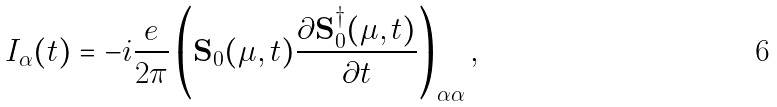<formula> <loc_0><loc_0><loc_500><loc_500>I _ { \alpha } ( t ) = - i \frac { e } { 2 \pi } \left ( { \mathbf S } _ { 0 } ( \mu , t ) \frac { \partial { \mathbf S } _ { 0 } ^ { \dagger } ( \mu , t ) } { \partial t } \right ) _ { \alpha \alpha } ,</formula> 